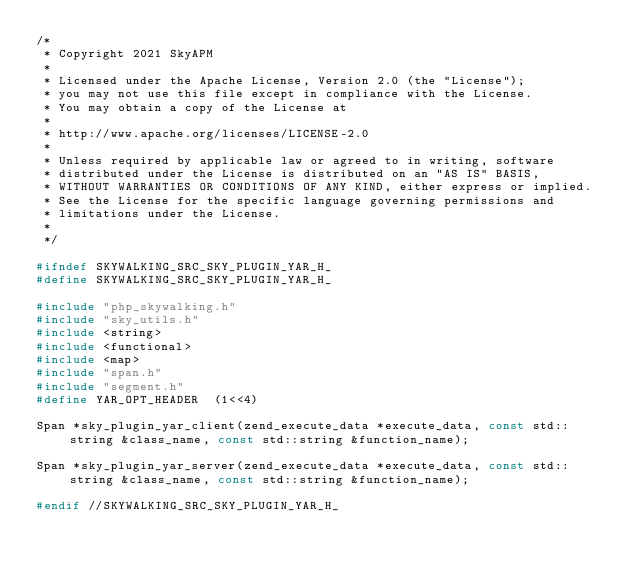<code> <loc_0><loc_0><loc_500><loc_500><_C_>/*
 * Copyright 2021 SkyAPM
 *
 * Licensed under the Apache License, Version 2.0 (the "License");
 * you may not use this file except in compliance with the License.
 * You may obtain a copy of the License at
 *
 * http://www.apache.org/licenses/LICENSE-2.0
 *
 * Unless required by applicable law or agreed to in writing, software
 * distributed under the License is distributed on an "AS IS" BASIS,
 * WITHOUT WARRANTIES OR CONDITIONS OF ANY KIND, either express or implied.
 * See the License for the specific language governing permissions and
 * limitations under the License.
 *
 */

#ifndef SKYWALKING_SRC_SKY_PLUGIN_YAR_H_
#define SKYWALKING_SRC_SKY_PLUGIN_YAR_H_

#include "php_skywalking.h"
#include "sky_utils.h"
#include <string>
#include <functional>
#include <map>
#include "span.h"
#include "segment.h"
#define YAR_OPT_HEADER	(1<<4)

Span *sky_plugin_yar_client(zend_execute_data *execute_data, const std::string &class_name, const std::string &function_name);

Span *sky_plugin_yar_server(zend_execute_data *execute_data, const std::string &class_name, const std::string &function_name);

#endif //SKYWALKING_SRC_SKY_PLUGIN_YAR_H_
</code> 